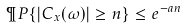Convert formula to latex. <formula><loc_0><loc_0><loc_500><loc_500>\P P \{ | C _ { x } ( \omega ) | \geq n \} \leq e ^ { - a n }</formula> 